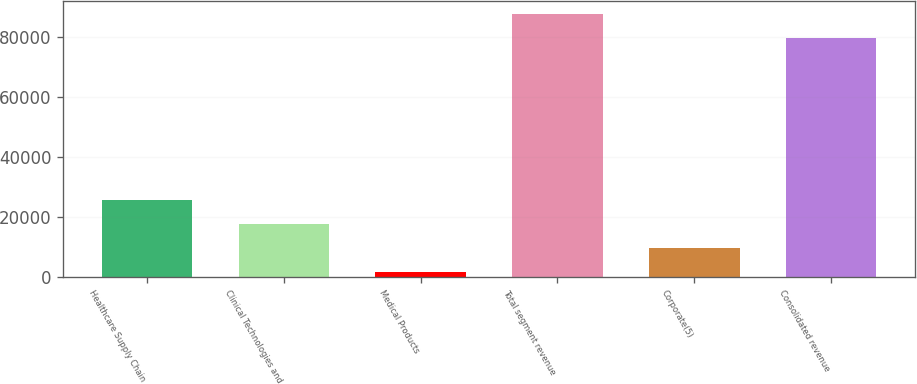<chart> <loc_0><loc_0><loc_500><loc_500><bar_chart><fcel>Healthcare Supply Chain<fcel>Clinical Technologies and<fcel>Medical Products<fcel>Total segment revenue<fcel>Corporate(5)<fcel>Consolidated revenue<nl><fcel>25535.6<fcel>17568.1<fcel>1632.9<fcel>87631.8<fcel>9600.48<fcel>79664.2<nl></chart> 